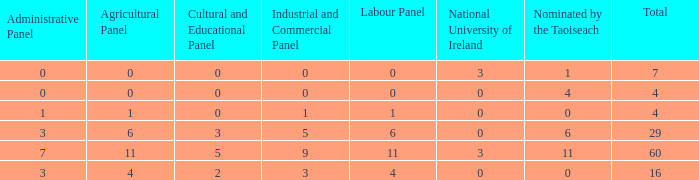What is the typical administrative committee of the composition designated by taoiseach 0 times with a total under 4? None. 